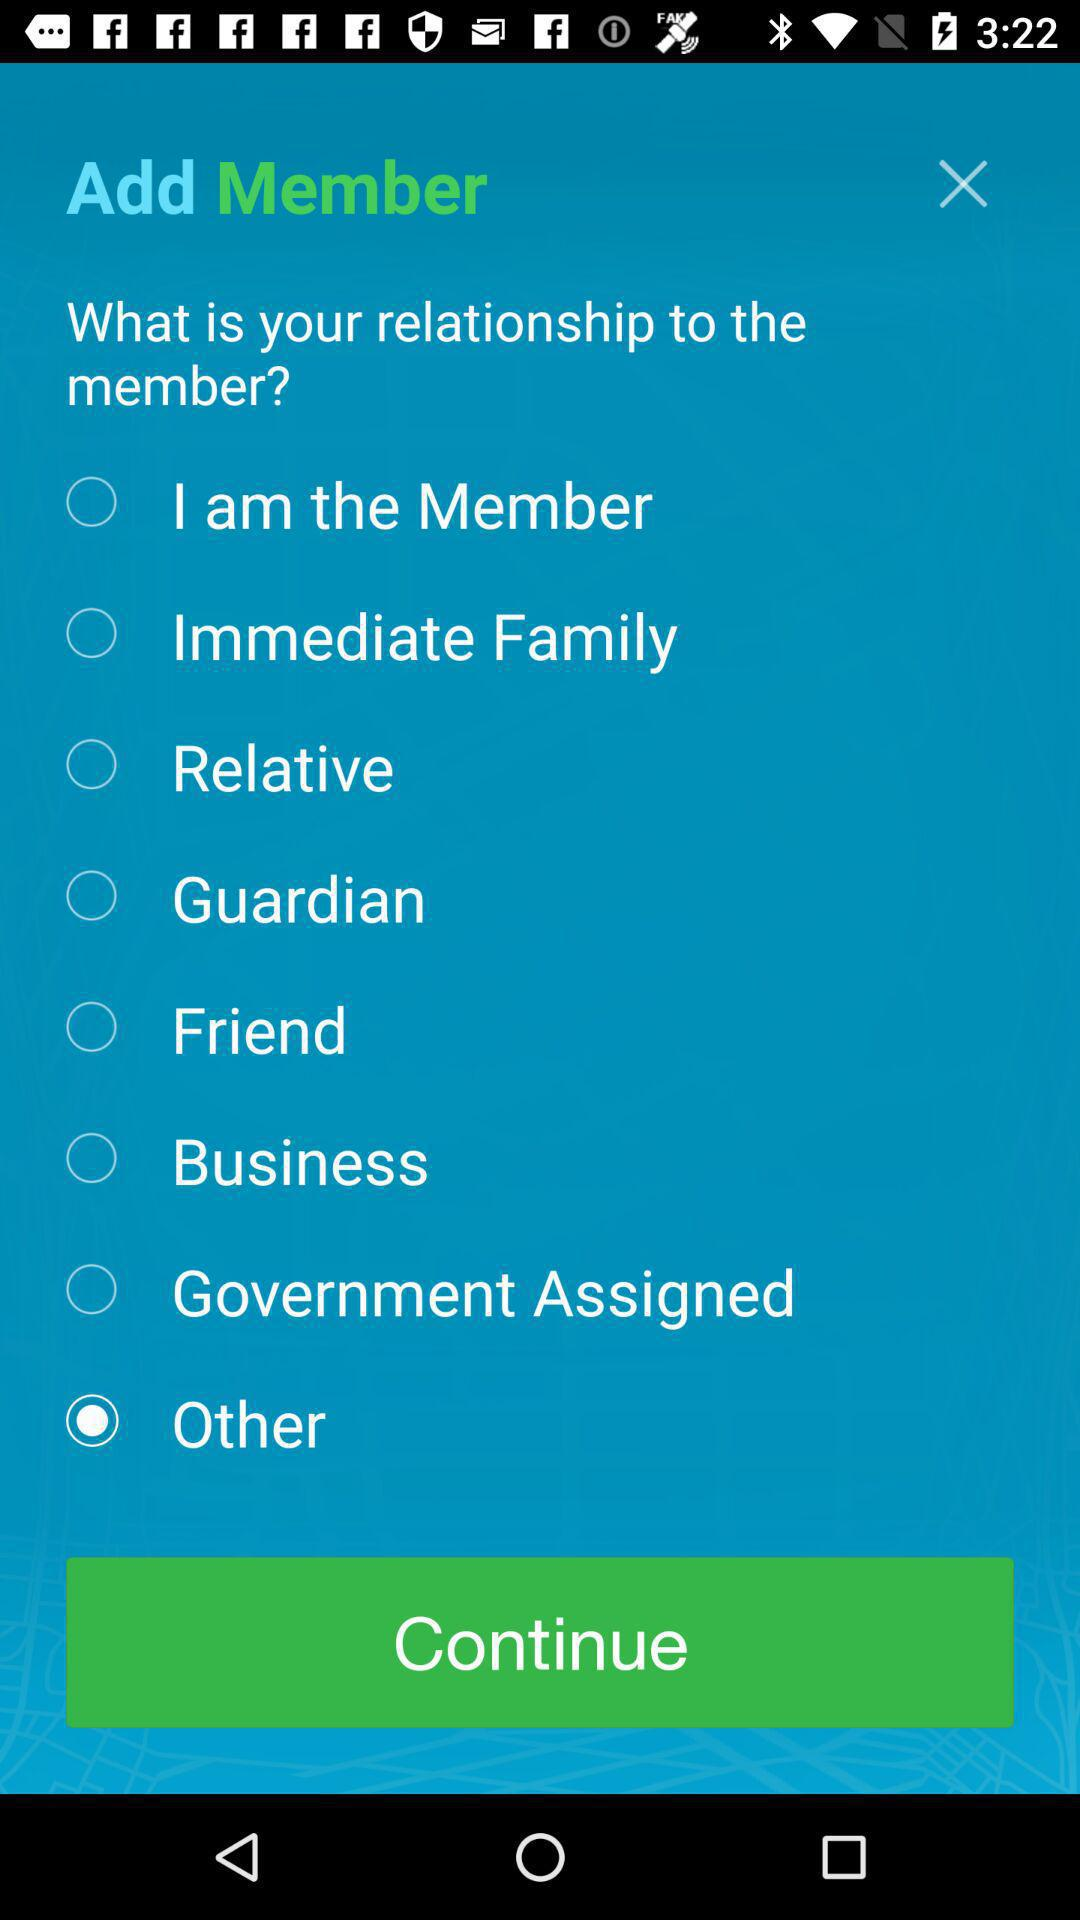What is the selected option? The selected option is "Other". 